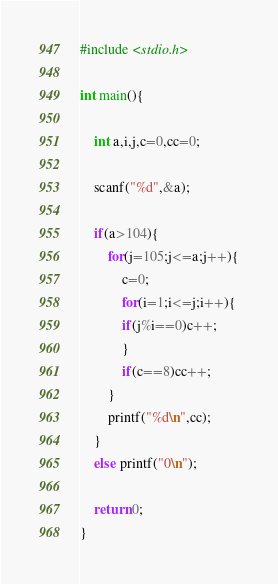Convert code to text. <code><loc_0><loc_0><loc_500><loc_500><_C_>#include <stdio.h>

int main(){
	
	int a,i,j,c=0,cc=0;
	
	scanf("%d",&a);
	
	if(a>104){
		for(j=105;j<=a;j++){
			c=0;
			for(i=1;i<=j;i++){
			if(j%i==0)c++;
			}
			if(c==8)cc++;
		}
		printf("%d\n",cc);
	}
	else printf("0\n");
	
	return 0;
}
</code> 